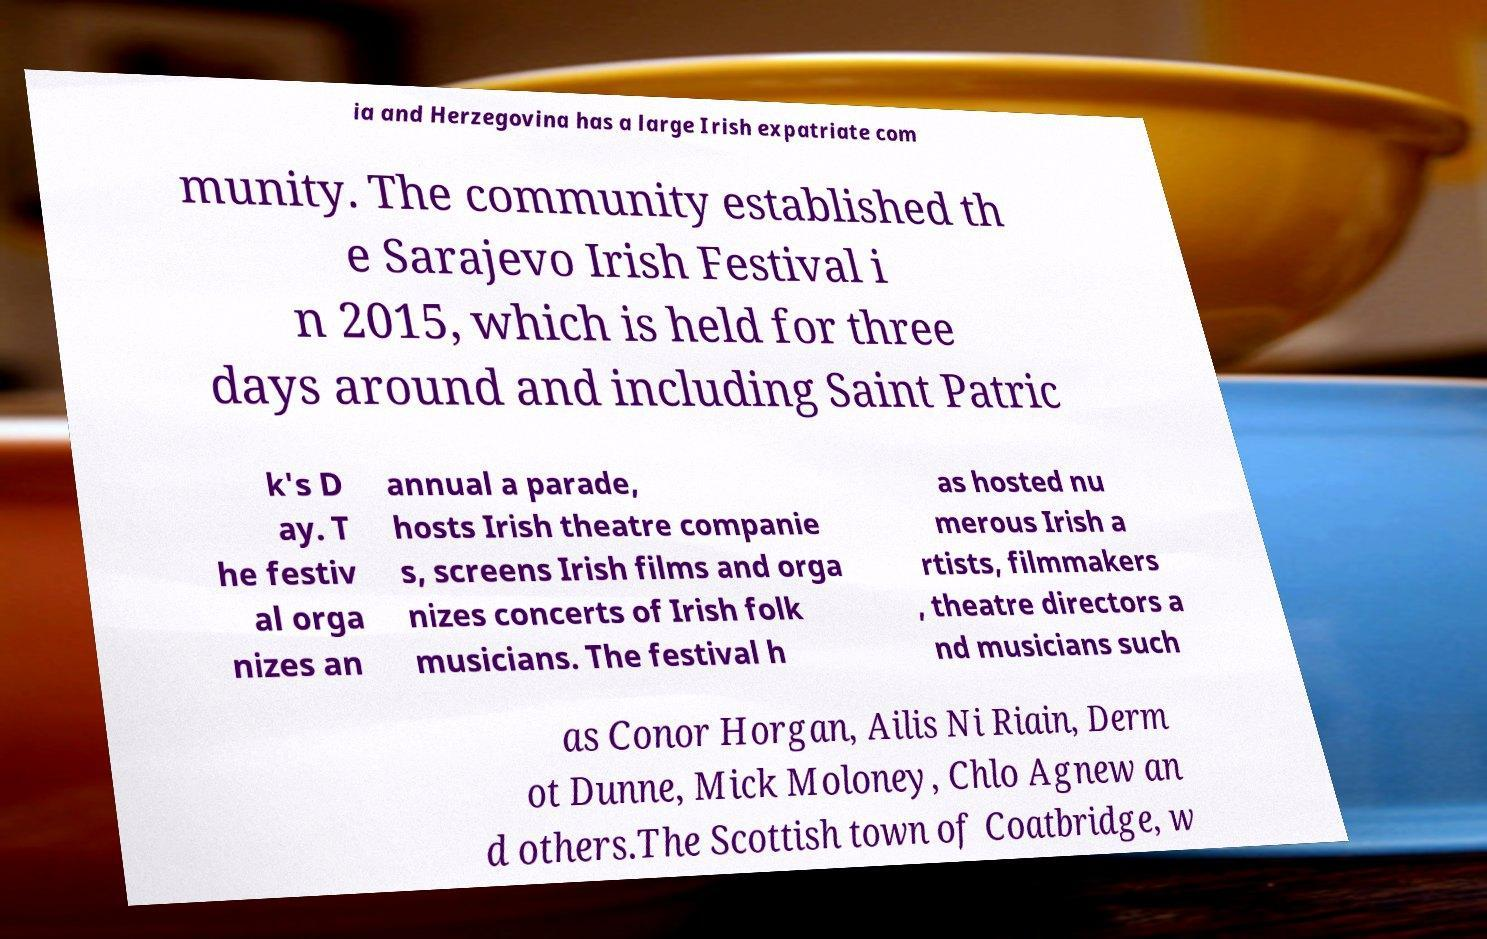What messages or text are displayed in this image? I need them in a readable, typed format. ia and Herzegovina has a large Irish expatriate com munity. The community established th e Sarajevo Irish Festival i n 2015, which is held for three days around and including Saint Patric k's D ay. T he festiv al orga nizes an annual a parade, hosts Irish theatre companie s, screens Irish films and orga nizes concerts of Irish folk musicians. The festival h as hosted nu merous Irish a rtists, filmmakers , theatre directors a nd musicians such as Conor Horgan, Ailis Ni Riain, Derm ot Dunne, Mick Moloney, Chlo Agnew an d others.The Scottish town of Coatbridge, w 